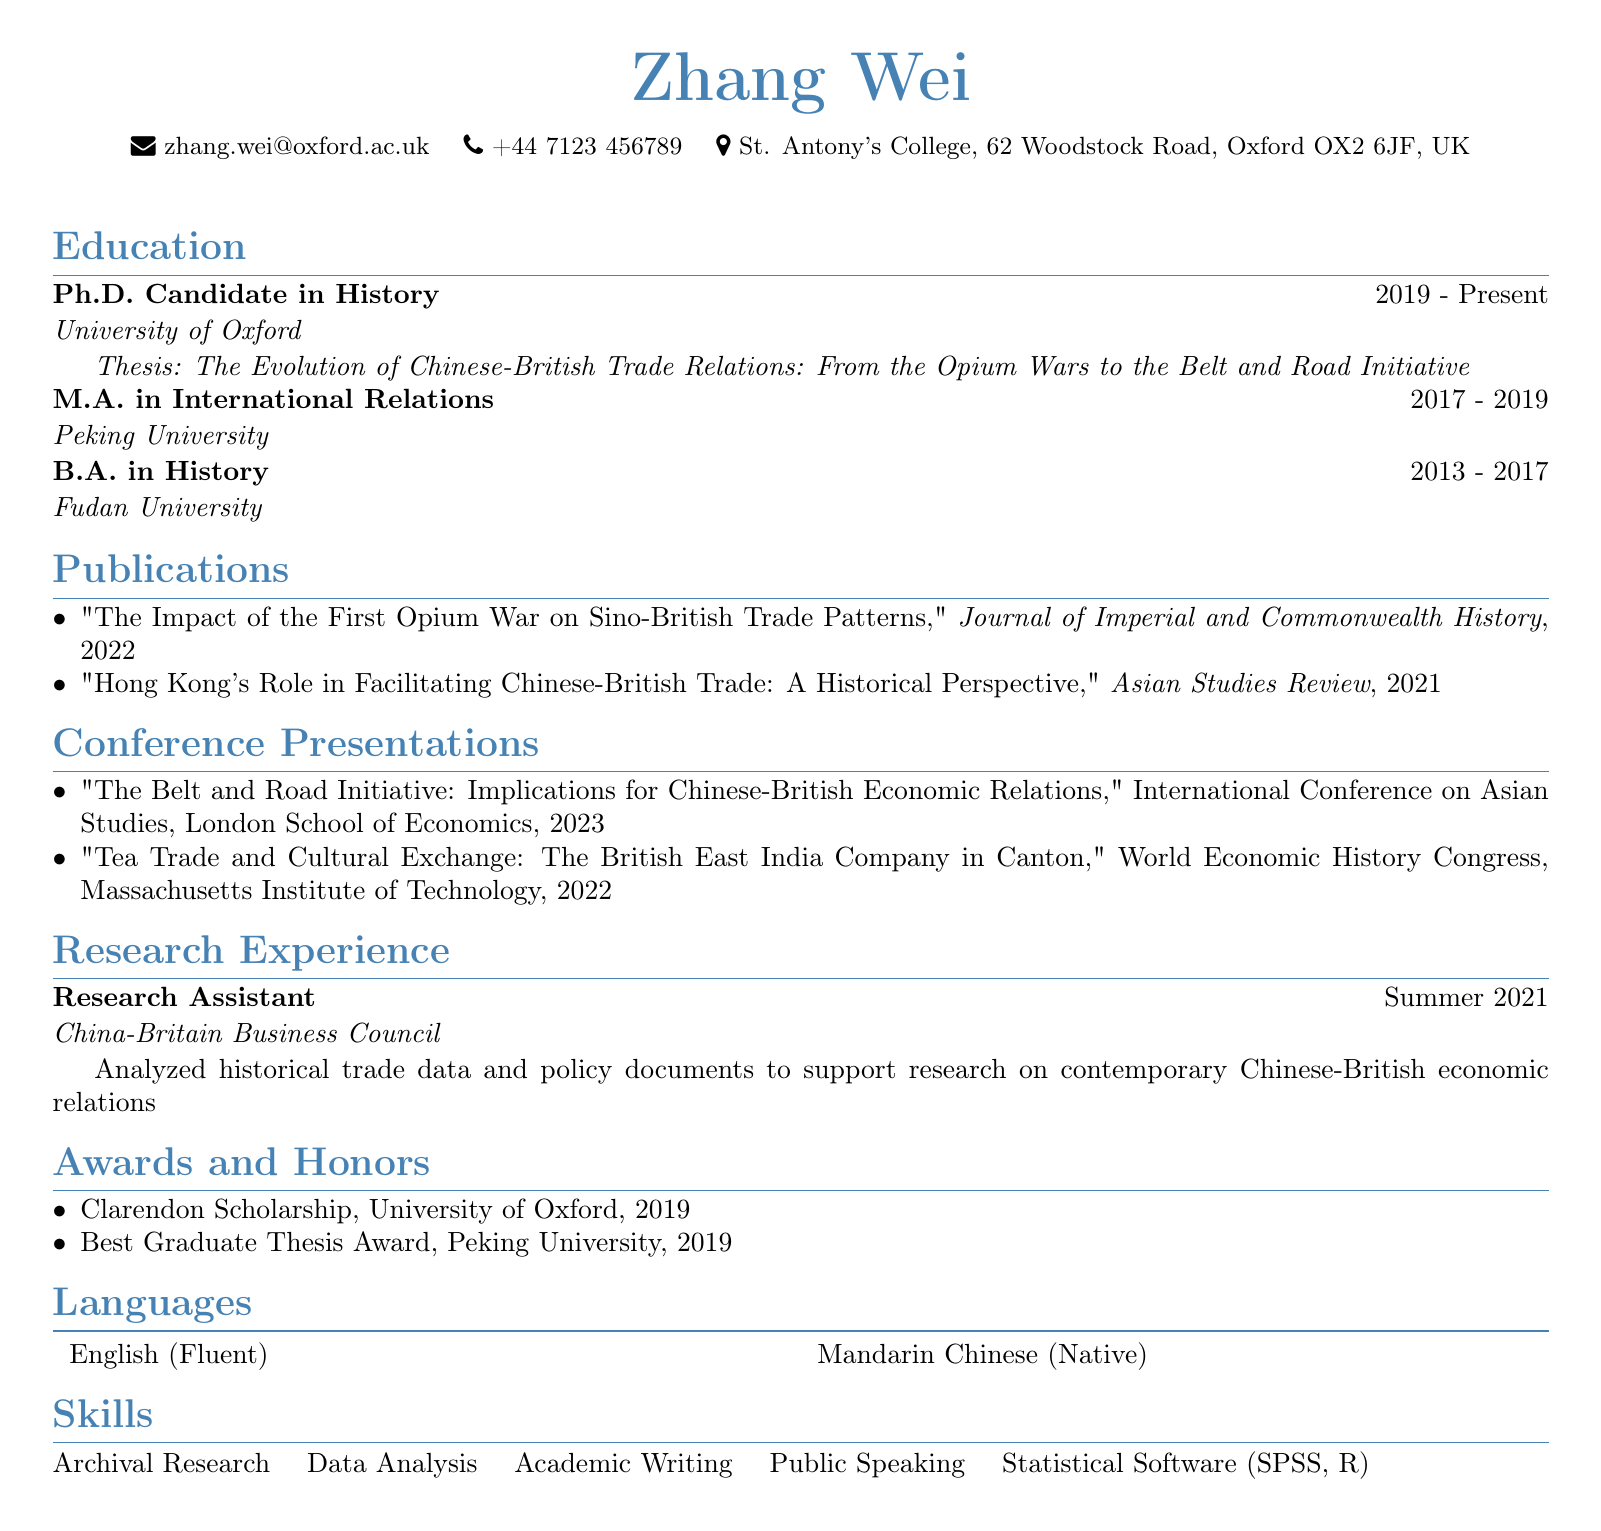what is the name of the candidate? The document lists the candidate's name as Zhang Wei.
Answer: Zhang Wei what is the thesis title? The thesis title is provided under the education section for the Ph.D. Candidate degree.
Answer: The Evolution of Chinese-British Trade Relations: From the Opium Wars to the Belt and Road Initiative which university did the candidate attend for their M.A.? The document specifies the university for the M.A. in International Relations.
Answer: Peking University how many publications are listed? The document lists the number of publications in the publications section.
Answer: 2 in what year was the Clarendon Scholarship awarded? The document mentions this award under the awards section.
Answer: 2019 which conference took place in 2023? The document provides the year for the conference presentations listed.
Answer: International Conference on Asian Studies what role did the candidate hold at the China-Britain Business Council? The document describes the candidate's position during their research experience.
Answer: Research Assistant which statistical software is mentioned in the skills section? The skills section lists specific statistical software that the candidate is proficient in.
Answer: SPSS, R 